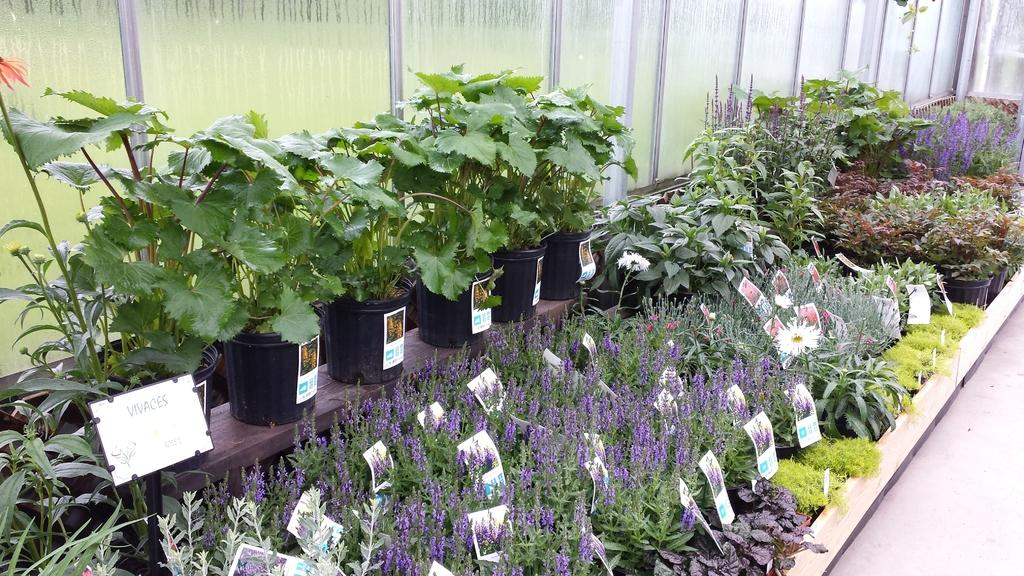What type of room is shown in the image? The image depicts a nursery. What decorative items can be seen in the nursery? There are stickers in the nursery. What is the purpose of the board in the nursery? There is a board in the nursery, which might be used for displaying information or artwork. What feature allows for visibility between different areas in the nursery? There is a glass wall in the nursery. What can be seen on the floor in the nursery? The floor is visible in the nursery. What type of band is playing music in the nursery? There is no band present in the nursery; it is a room for children and does not feature any musical performances. Can you find a receipt for the stickers on the floor in the nursery? There is no mention of a receipt in the image, and it is unlikely that a receipt would be present in a nursery setting. 